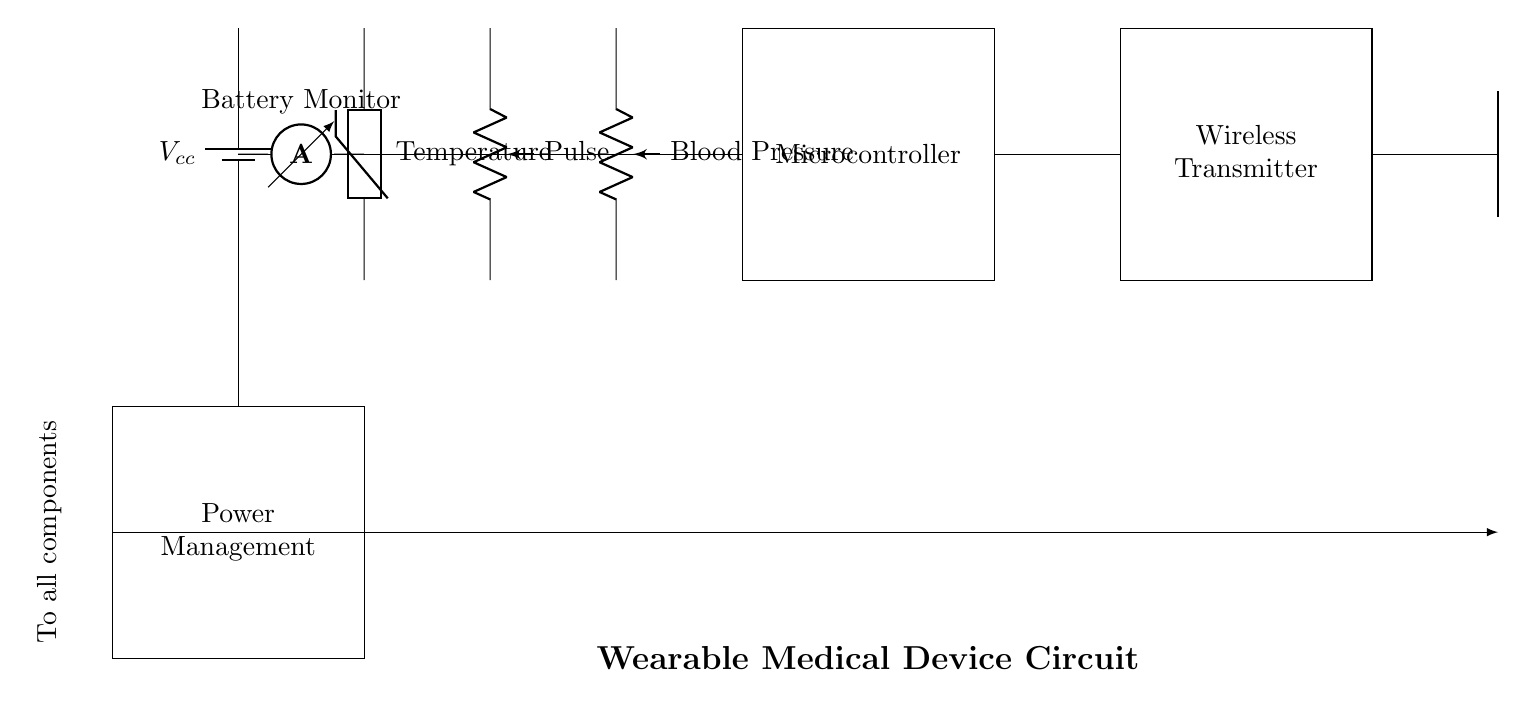What are the main components in the circuit? The circuit consists of a battery, thermistor, pulse sensor, blood pressure sensor, microcontroller, wireless transmitter, antenna, battery monitor, and power management module. These are visually identifiable elements in the diagram.
Answer: battery, thermistor, pulse sensor, blood pressure sensor, microcontroller, wireless transmitter, antenna, battery monitor, power management module What is the function of the thermistor in this circuit? The thermistor is a temperature sensor that measures the temperature of the patient's body, providing vital signs data to the microcontroller for monitoring.
Answer: temperature sensor How is the microcontroller connected to the sensors? The outputs of the thermistor, pulse sensor, and blood pressure sensor are individually connected to the microcontroller's input, allowing it to receive and process data from all three sensors simultaneously.
Answer: inputs from sensors What type of data is transmitted by the wireless module? The wireless module transmits collected vital sign data, including temperature, pulse, and blood pressure, wirelessly to a receiving device for remote monitoring.
Answer: vital signs data What is the purpose of the battery monitor in this circuit? The battery monitor ensures that the power supply to the device is functioning correctly by measuring the current draw from the battery, helping to prevent unexpected power loss.
Answer: monitor current What does the power management module do in this circuit? The power management module regulates the power supply to all components, ensuring that each part receives the appropriate voltage and current for reliable operation, especially important in a wearable device.
Answer: regulates power supply How does the antenna function in the circuit? The antenna facilitates the transmission of the wireless signals that carry vital signs data from the wearable device to a remote monitoring system, ensuring effective communication.
Answer: transmits signals 